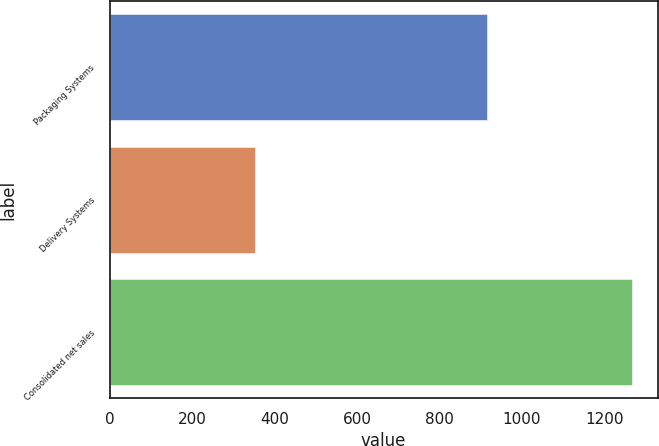Convert chart. <chart><loc_0><loc_0><loc_500><loc_500><bar_chart><fcel>Packaging Systems<fcel>Delivery Systems<fcel>Consolidated net sales<nl><fcel>915.1<fcel>352.1<fcel>1266.4<nl></chart> 